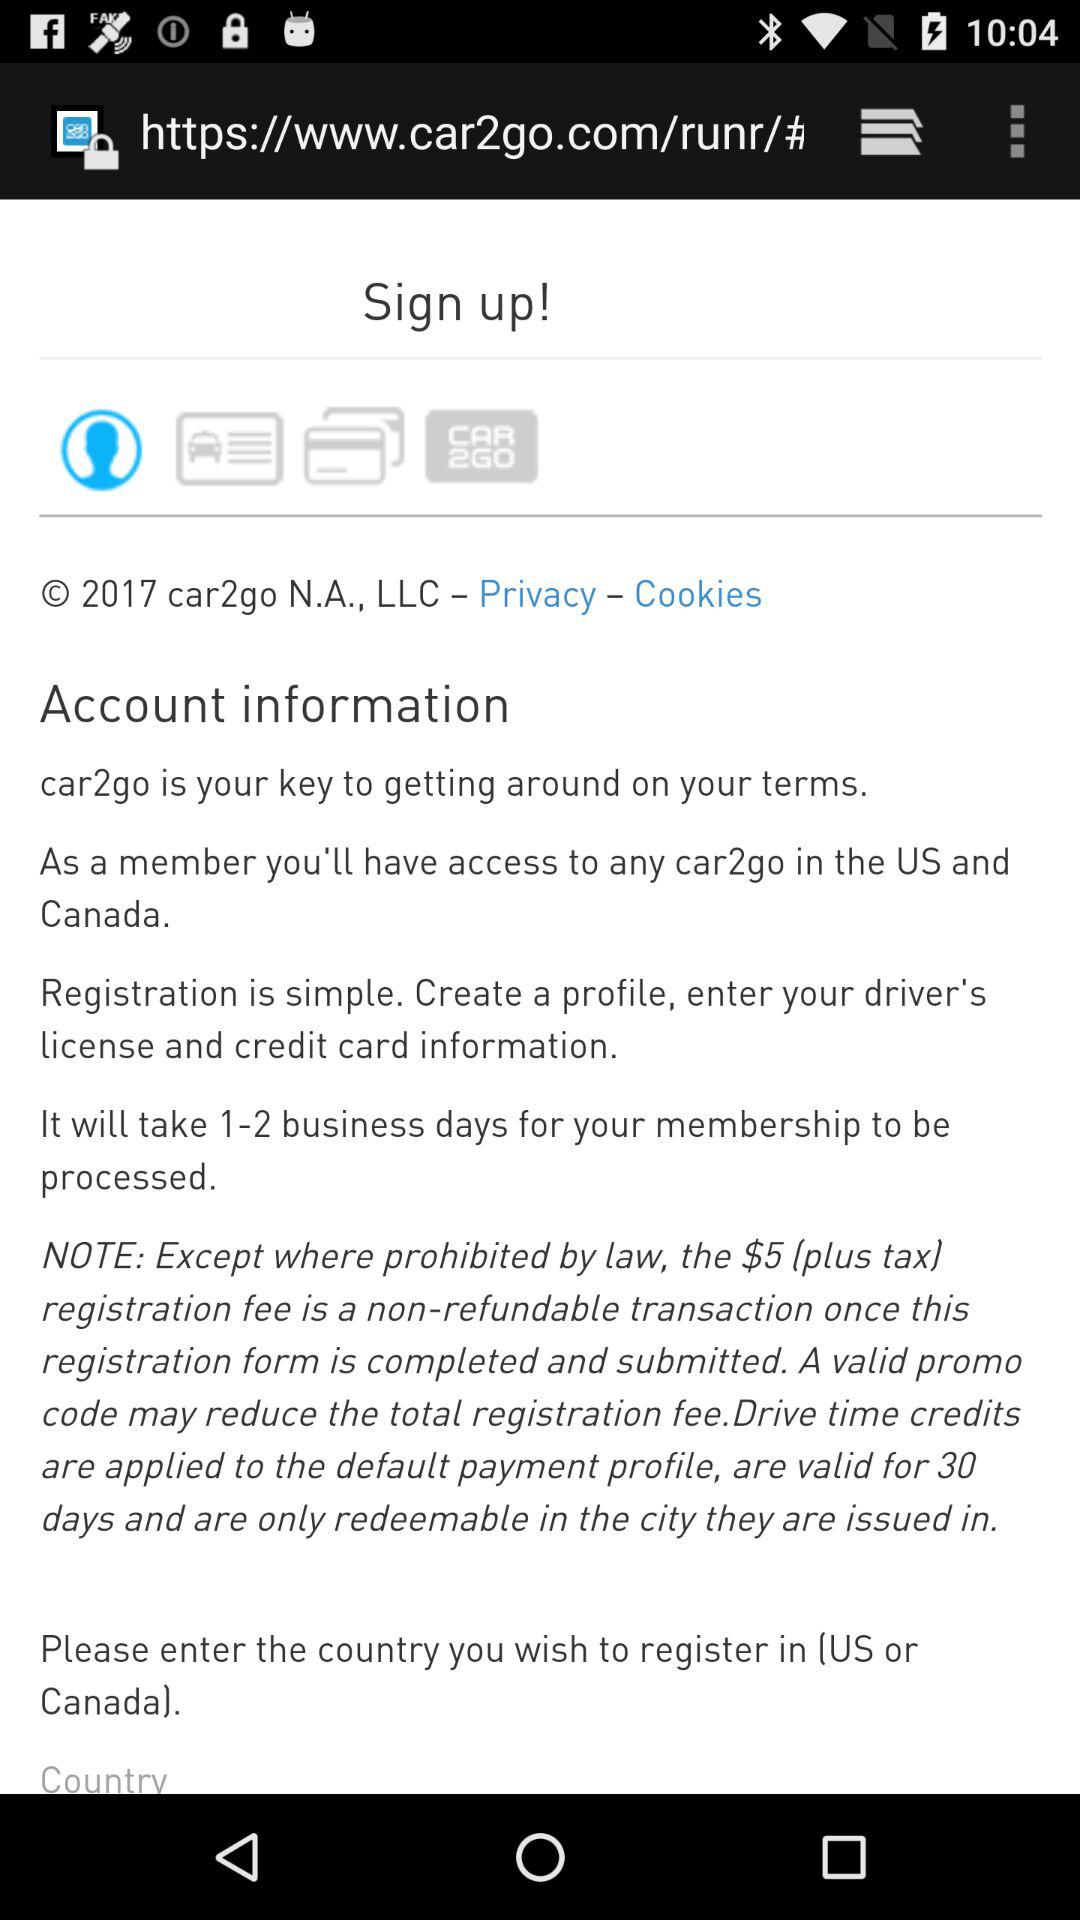How many countries are available for registration?
Answer the question using a single word or phrase. 2 